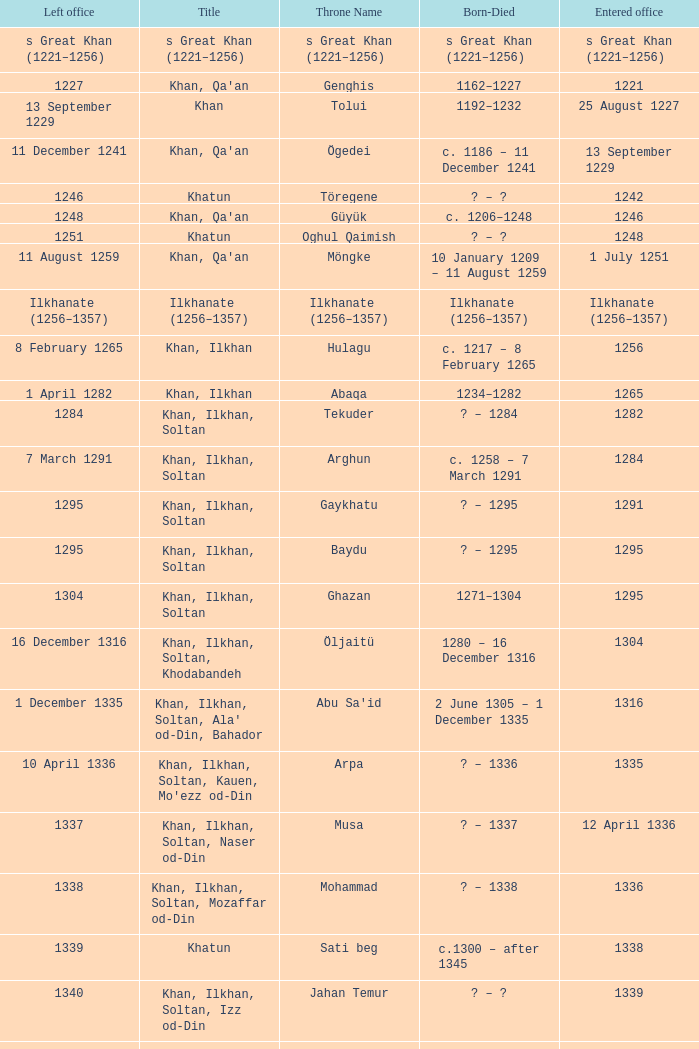What is the born-died that has office of 13 September 1229 as the entered? C. 1186 – 11 december 1241. 